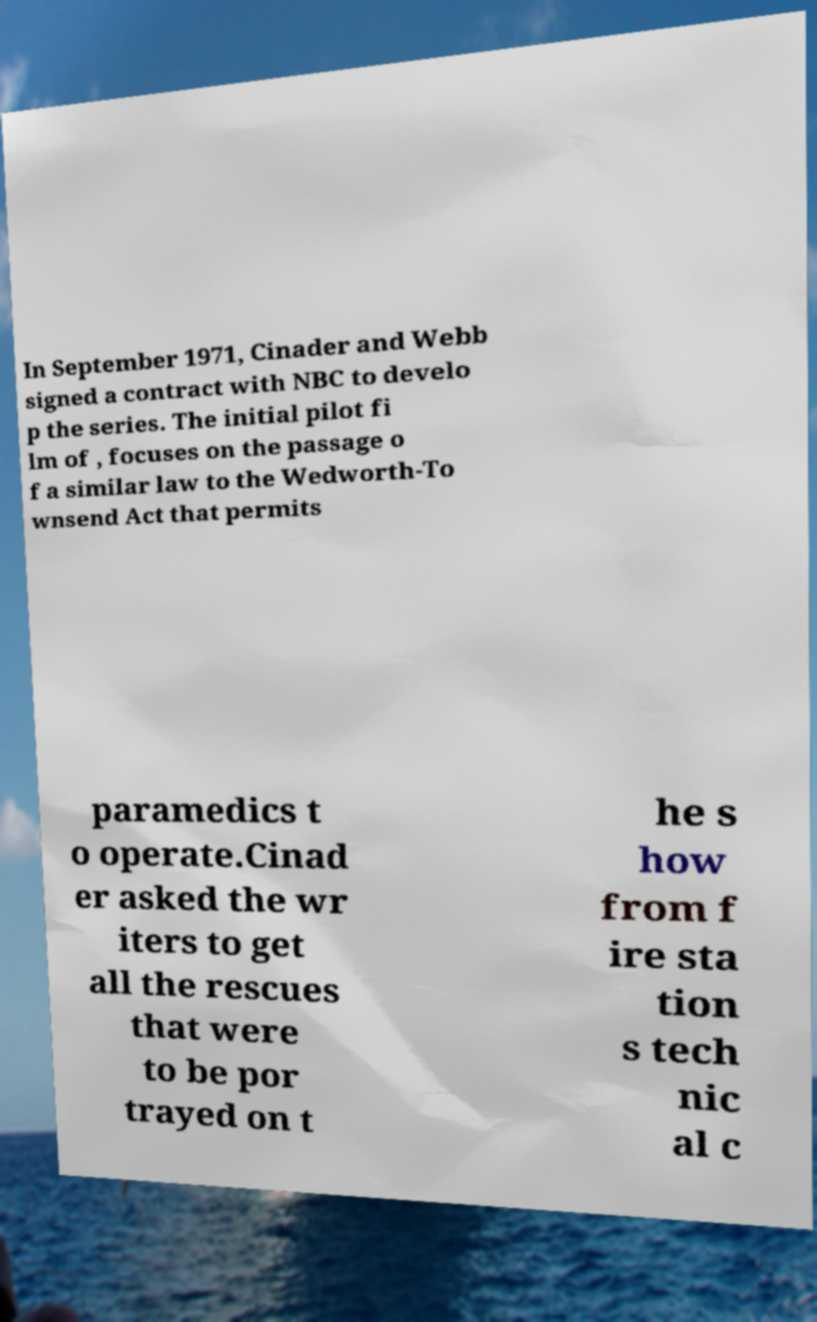Can you accurately transcribe the text from the provided image for me? In September 1971, Cinader and Webb signed a contract with NBC to develo p the series. The initial pilot fi lm of , focuses on the passage o f a similar law to the Wedworth-To wnsend Act that permits paramedics t o operate.Cinad er asked the wr iters to get all the rescues that were to be por trayed on t he s how from f ire sta tion s tech nic al c 